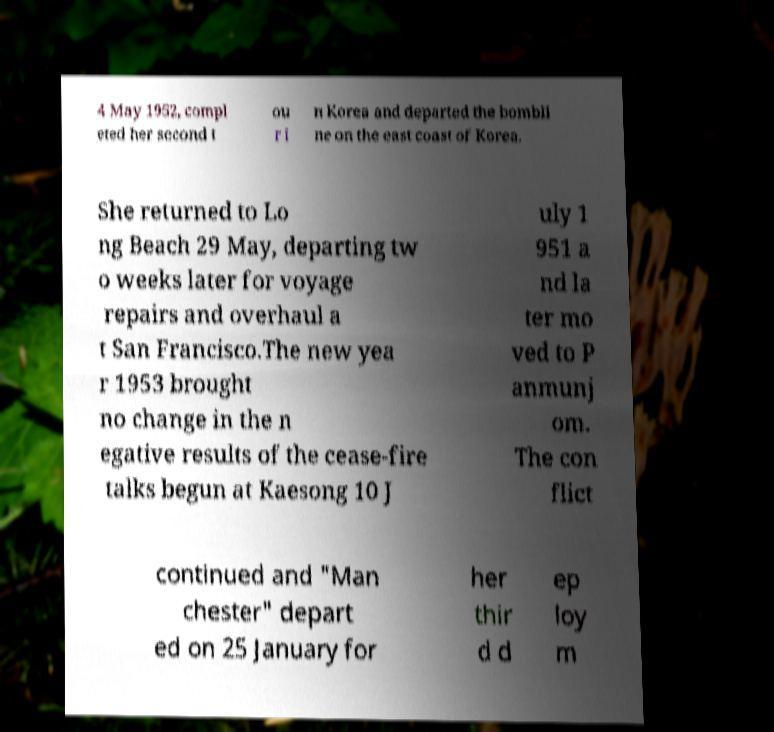What messages or text are displayed in this image? I need them in a readable, typed format. 4 May 1952, compl eted her second t ou r i n Korea and departed the bombli ne on the east coast of Korea. She returned to Lo ng Beach 29 May, departing tw o weeks later for voyage repairs and overhaul a t San Francisco.The new yea r 1953 brought no change in the n egative results of the cease-fire talks begun at Kaesong 10 J uly 1 951 a nd la ter mo ved to P anmunj om. The con flict continued and "Man chester" depart ed on 25 January for her thir d d ep loy m 